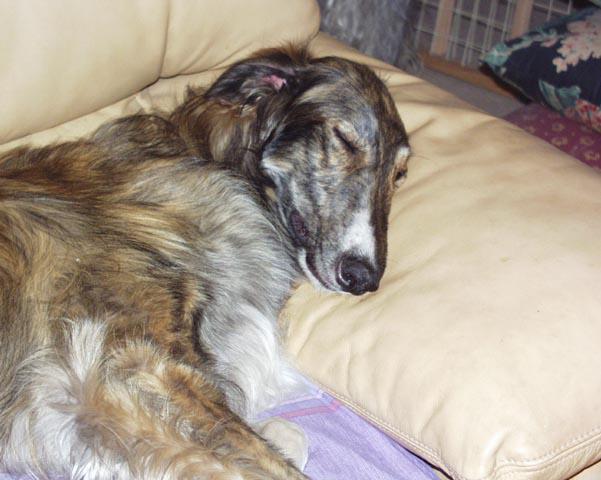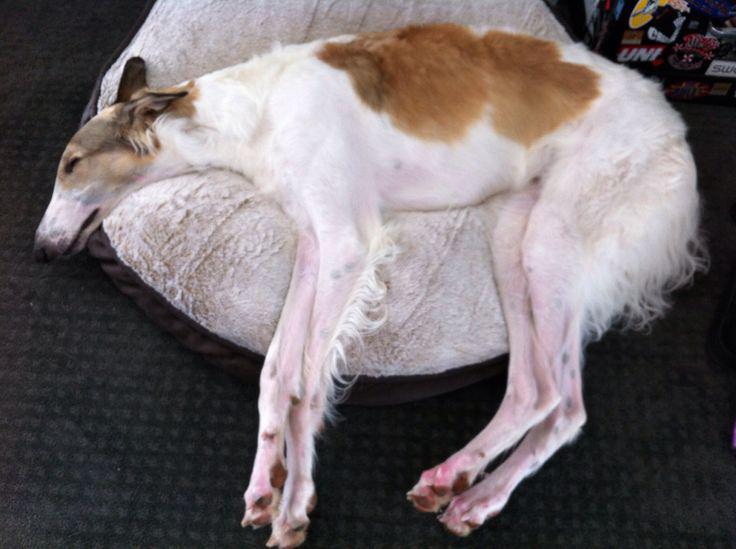The first image is the image on the left, the second image is the image on the right. Considering the images on both sides, is "Each image shows a hound lounging on upholstered furniture, and one image shows a hound upside-down with hind legs above his front paws." valid? Answer yes or no. No. The first image is the image on the left, the second image is the image on the right. Analyze the images presented: Is the assertion "At least one dog is laying on his back." valid? Answer yes or no. No. 